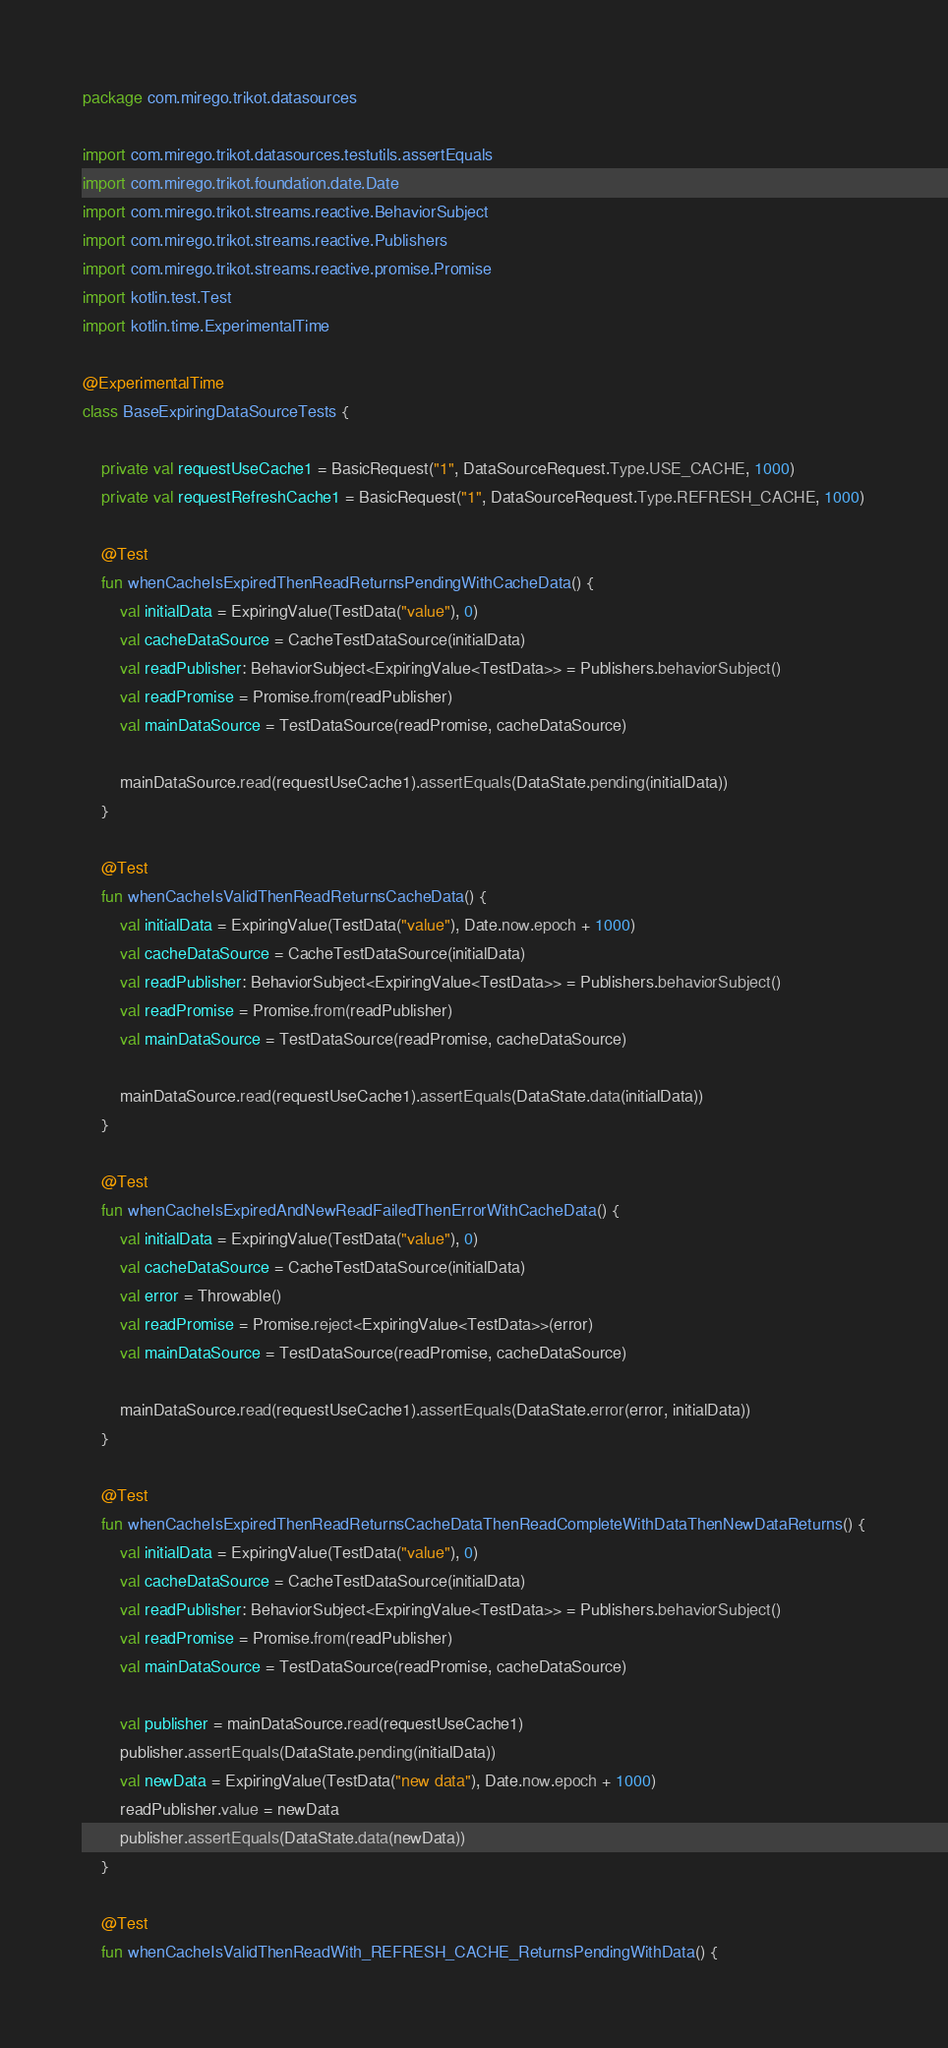<code> <loc_0><loc_0><loc_500><loc_500><_Kotlin_>package com.mirego.trikot.datasources

import com.mirego.trikot.datasources.testutils.assertEquals
import com.mirego.trikot.foundation.date.Date
import com.mirego.trikot.streams.reactive.BehaviorSubject
import com.mirego.trikot.streams.reactive.Publishers
import com.mirego.trikot.streams.reactive.promise.Promise
import kotlin.test.Test
import kotlin.time.ExperimentalTime

@ExperimentalTime
class BaseExpiringDataSourceTests {

    private val requestUseCache1 = BasicRequest("1", DataSourceRequest.Type.USE_CACHE, 1000)
    private val requestRefreshCache1 = BasicRequest("1", DataSourceRequest.Type.REFRESH_CACHE, 1000)

    @Test
    fun whenCacheIsExpiredThenReadReturnsPendingWithCacheData() {
        val initialData = ExpiringValue(TestData("value"), 0)
        val cacheDataSource = CacheTestDataSource(initialData)
        val readPublisher: BehaviorSubject<ExpiringValue<TestData>> = Publishers.behaviorSubject()
        val readPromise = Promise.from(readPublisher)
        val mainDataSource = TestDataSource(readPromise, cacheDataSource)

        mainDataSource.read(requestUseCache1).assertEquals(DataState.pending(initialData))
    }

    @Test
    fun whenCacheIsValidThenReadReturnsCacheData() {
        val initialData = ExpiringValue(TestData("value"), Date.now.epoch + 1000)
        val cacheDataSource = CacheTestDataSource(initialData)
        val readPublisher: BehaviorSubject<ExpiringValue<TestData>> = Publishers.behaviorSubject()
        val readPromise = Promise.from(readPublisher)
        val mainDataSource = TestDataSource(readPromise, cacheDataSource)

        mainDataSource.read(requestUseCache1).assertEquals(DataState.data(initialData))
    }

    @Test
    fun whenCacheIsExpiredAndNewReadFailedThenErrorWithCacheData() {
        val initialData = ExpiringValue(TestData("value"), 0)
        val cacheDataSource = CacheTestDataSource(initialData)
        val error = Throwable()
        val readPromise = Promise.reject<ExpiringValue<TestData>>(error)
        val mainDataSource = TestDataSource(readPromise, cacheDataSource)

        mainDataSource.read(requestUseCache1).assertEquals(DataState.error(error, initialData))
    }

    @Test
    fun whenCacheIsExpiredThenReadReturnsCacheDataThenReadCompleteWithDataThenNewDataReturns() {
        val initialData = ExpiringValue(TestData("value"), 0)
        val cacheDataSource = CacheTestDataSource(initialData)
        val readPublisher: BehaviorSubject<ExpiringValue<TestData>> = Publishers.behaviorSubject()
        val readPromise = Promise.from(readPublisher)
        val mainDataSource = TestDataSource(readPromise, cacheDataSource)

        val publisher = mainDataSource.read(requestUseCache1)
        publisher.assertEquals(DataState.pending(initialData))
        val newData = ExpiringValue(TestData("new data"), Date.now.epoch + 1000)
        readPublisher.value = newData
        publisher.assertEquals(DataState.data(newData))
    }

    @Test
    fun whenCacheIsValidThenReadWith_REFRESH_CACHE_ReturnsPendingWithData() {</code> 